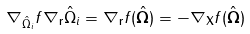<formula> <loc_0><loc_0><loc_500><loc_500>\nabla _ { \hat { \Omega } _ { i } } f \nabla _ { \mathbf r } \hat { \Omega } _ { i } = \nabla _ { \mathbf r } f ( \hat { \mathbf \Omega } ) = - \nabla _ { \mathbf X } f ( \hat { \mathbf \Omega } )</formula> 